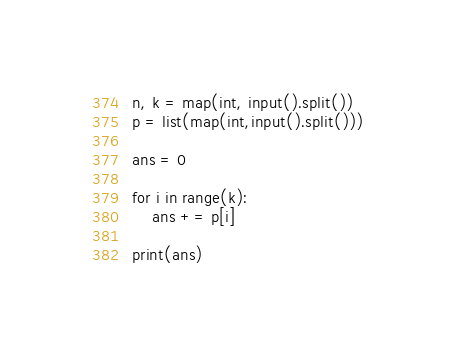<code> <loc_0><loc_0><loc_500><loc_500><_Python_>n, k = map(int, input().split())
p = list(map(int,input().split()))

ans = 0

for i in range(k):
    ans += p[i]

print(ans)</code> 